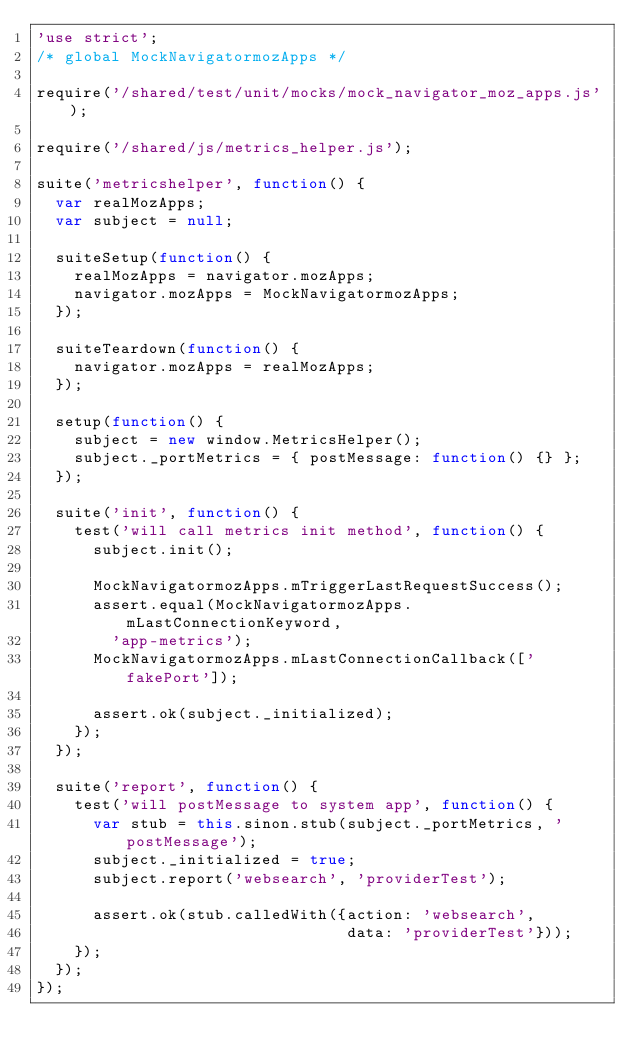<code> <loc_0><loc_0><loc_500><loc_500><_JavaScript_>'use strict';
/* global MockNavigatormozApps */

require('/shared/test/unit/mocks/mock_navigator_moz_apps.js');

require('/shared/js/metrics_helper.js');

suite('metricshelper', function() {
  var realMozApps;
  var subject = null;

  suiteSetup(function() {
    realMozApps = navigator.mozApps;
    navigator.mozApps = MockNavigatormozApps;
  });

  suiteTeardown(function() {
    navigator.mozApps = realMozApps;
  });

  setup(function() {
    subject = new window.MetricsHelper();
    subject._portMetrics = { postMessage: function() {} };
  });

  suite('init', function() {
    test('will call metrics init method', function() {
      subject.init();

      MockNavigatormozApps.mTriggerLastRequestSuccess();
      assert.equal(MockNavigatormozApps.mLastConnectionKeyword,
        'app-metrics');
      MockNavigatormozApps.mLastConnectionCallback(['fakePort']);

      assert.ok(subject._initialized);
    });
  });

  suite('report', function() {
    test('will postMessage to system app', function() {
      var stub = this.sinon.stub(subject._portMetrics, 'postMessage');
      subject._initialized = true;
      subject.report('websearch', 'providerTest');

      assert.ok(stub.calledWith({action: 'websearch',
                                 data: 'providerTest'}));
    });
  });
});
</code> 